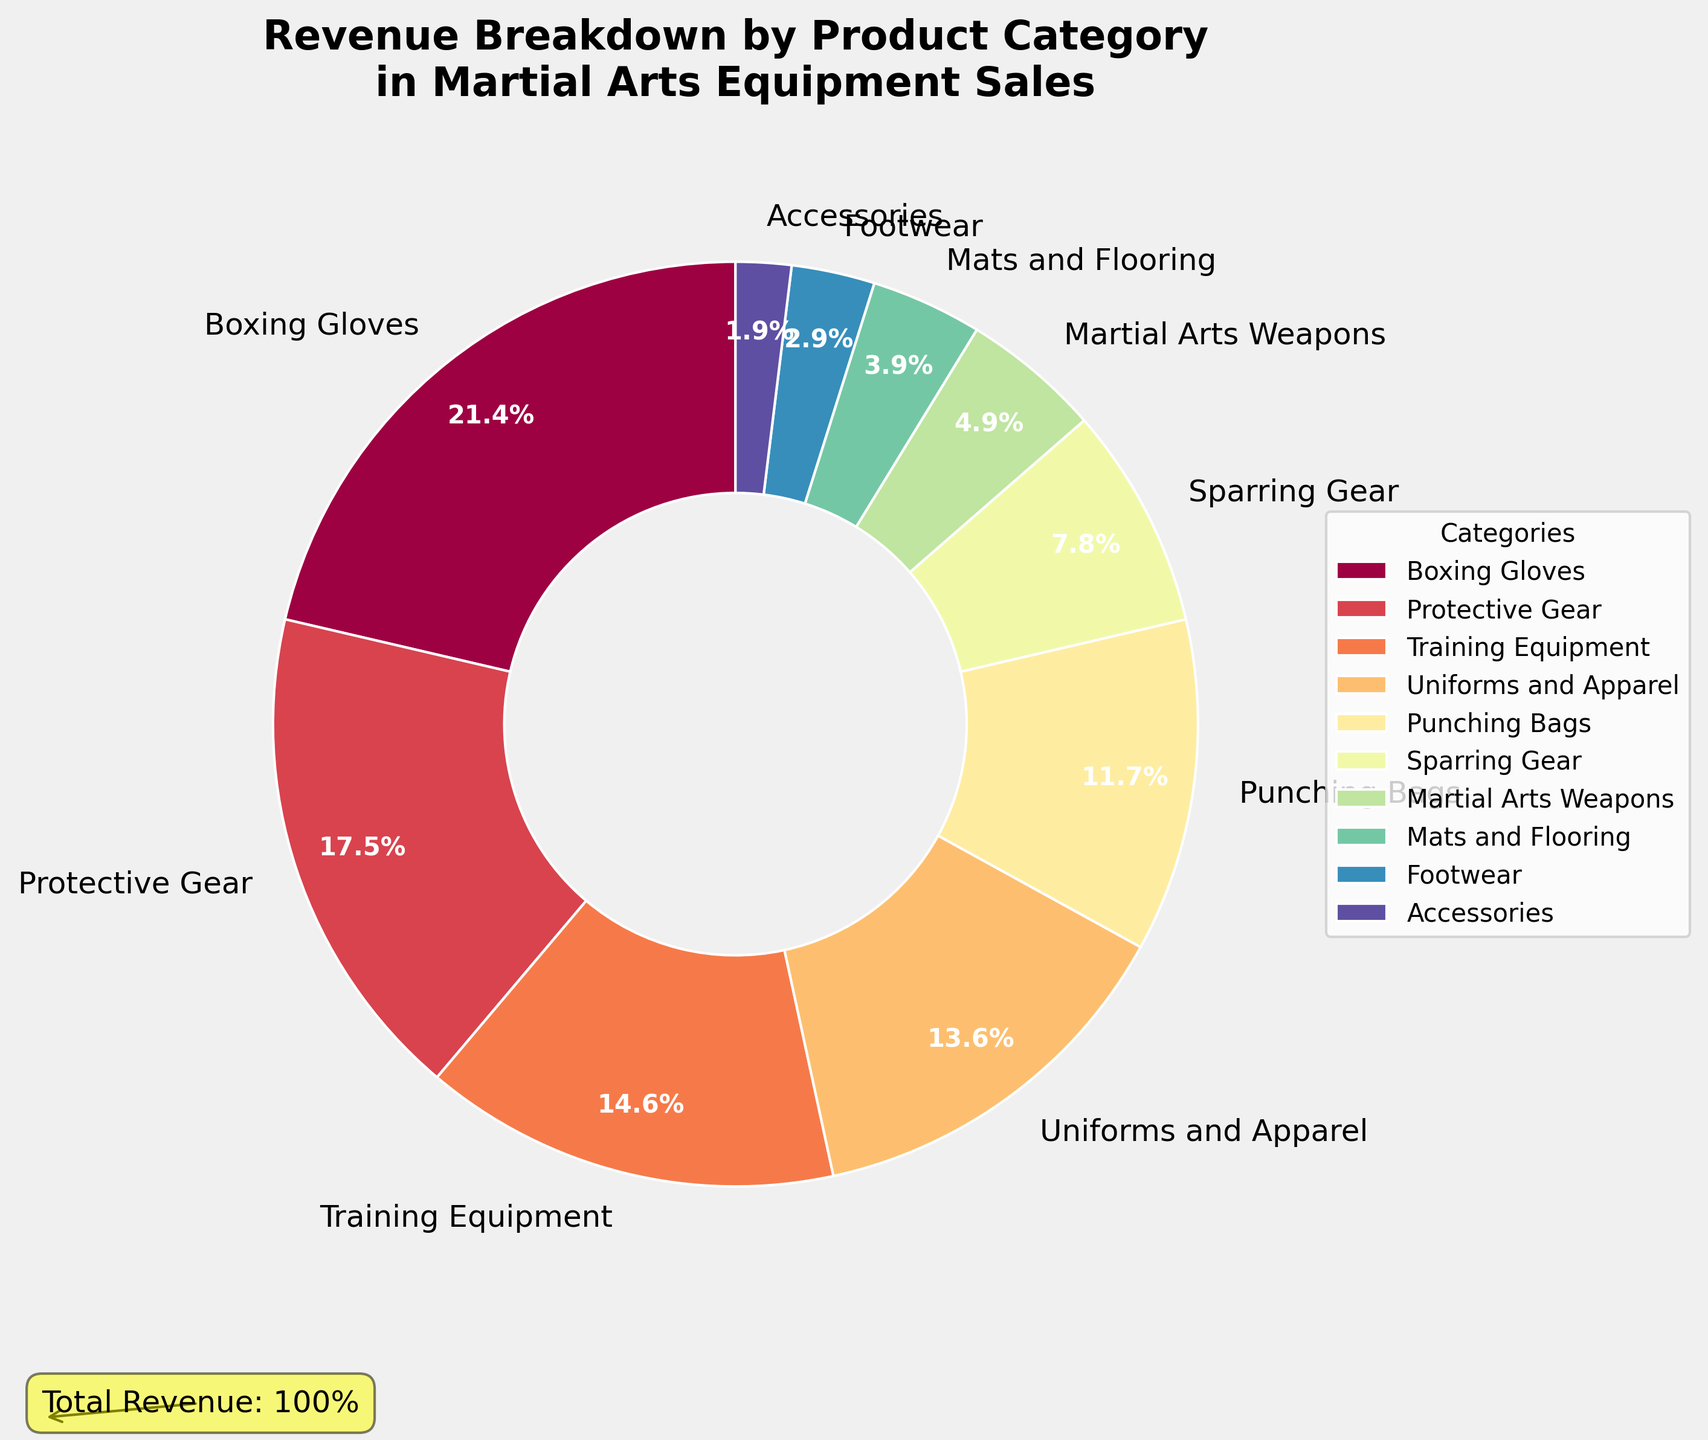What's the category with the highest revenue percentage? By looking at the pie chart, the largest segment will represent the category with the highest revenue percentage. The largest segment is labeled "Boxing Gloves" with 22%.
Answer: Boxing Gloves What's the combined revenue percentage of Protective Gear and Training Equipment? Add the revenue percentages of Protective Gear and Training Equipment together. Protective Gear is 18% and Training Equipment is 15%. 18% + 15% = 33%
Answer: 33% Which category contributes less revenue, Footwear or Accessories? Comparing the two segments labeled Footwear and Accessories, Footwear has 3% and Accessories has 2%. Since 2% is less than 3%, Accessories contributes less revenue.
Answer: Accessories How much greater is the revenue percentage of Uniforms and Apparel compared to Sparring Gear? Subtract the revenue percentage of Sparring Gear from that of Uniforms and Apparel. Uniforms and Apparel is 14% and Sparring Gear is 8%. 14% - 8% = 6%
Answer: 6% Which three categories contribute the least to the overall revenue? Identify the three smallest segments in the pie chart. These are "Accessories" (2%), "Footwear" (3%), and "Mats and Flooring" (4%).
Answer: Accessories, Footwear, Mats and Flooring Is the revenue percentage of Punching Bags more than the sum of Martial Arts Weapons and Accessories? Compare the revenue percentage of Punching Bags (12%) to the sum of Martial Arts Weapons (5%) and Accessories (2%). 5% + 2% = 7%, and 12% is indeed greater than 7%.
Answer: Yes What's the average revenue percentage of the top four categories? Add the revenue percentages of the top four categories (Boxing Gloves, Protective Gear, Training Equipment, and Uniforms and Apparel) and then divide by four. (22% + 18% + 15% + 14%) / 4 = 69% / 4 = 17.25%
Answer: 17.25% How much greater is the combined revenue percentage of the top two categories compared to the bottom two categories? Calculate the combined revenue percentage of the top two categories (Boxing Gloves and Protective Gear) and the bottom two categories (Accessories and Footwear), then find the difference. Top two: 22% + 18% = 40%, bottom two: 3% + 2% = 5%, difference: 40% - 5% = 35%
Answer: 35% How do the visual attributes of the pie chart help in identifying which category has the highest revenue? The segment with the highest revenue will appear larger in the pie chart, making it visually prominent. Additionally, different colors help distinguish between segments easily. The segment labeled "Boxing Gloves" is visibly the largest.
Answer: Largest segment Are Training Equipment's and Punching Bags' revenue percentages together greater than the revenue percentage of Boxing Gloves? Add the percentages of Training Equipment and Punching Bags and compare to Boxing Gloves. Training Equipment is 15% and Punching Bags is 12%, sum is 27%. Boxing Gloves is 22%, and 27% is greater than 22%.
Answer: Yes 